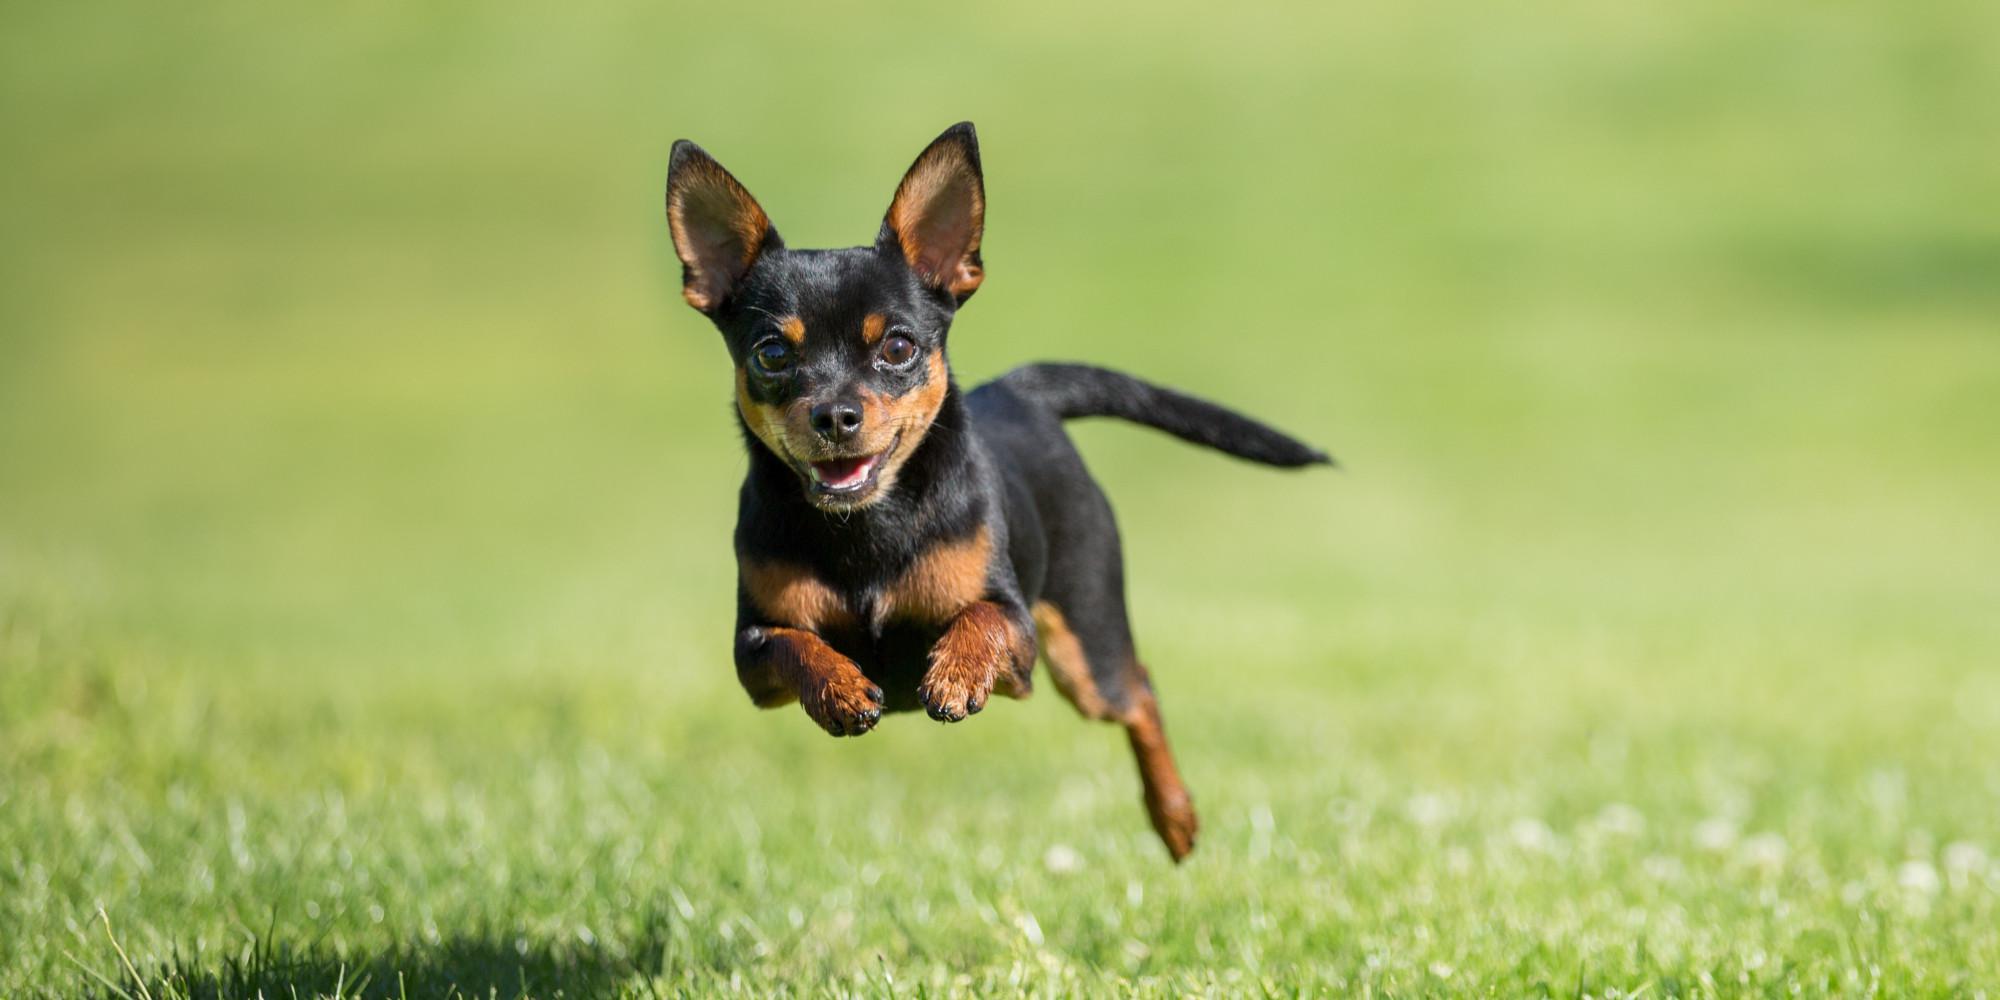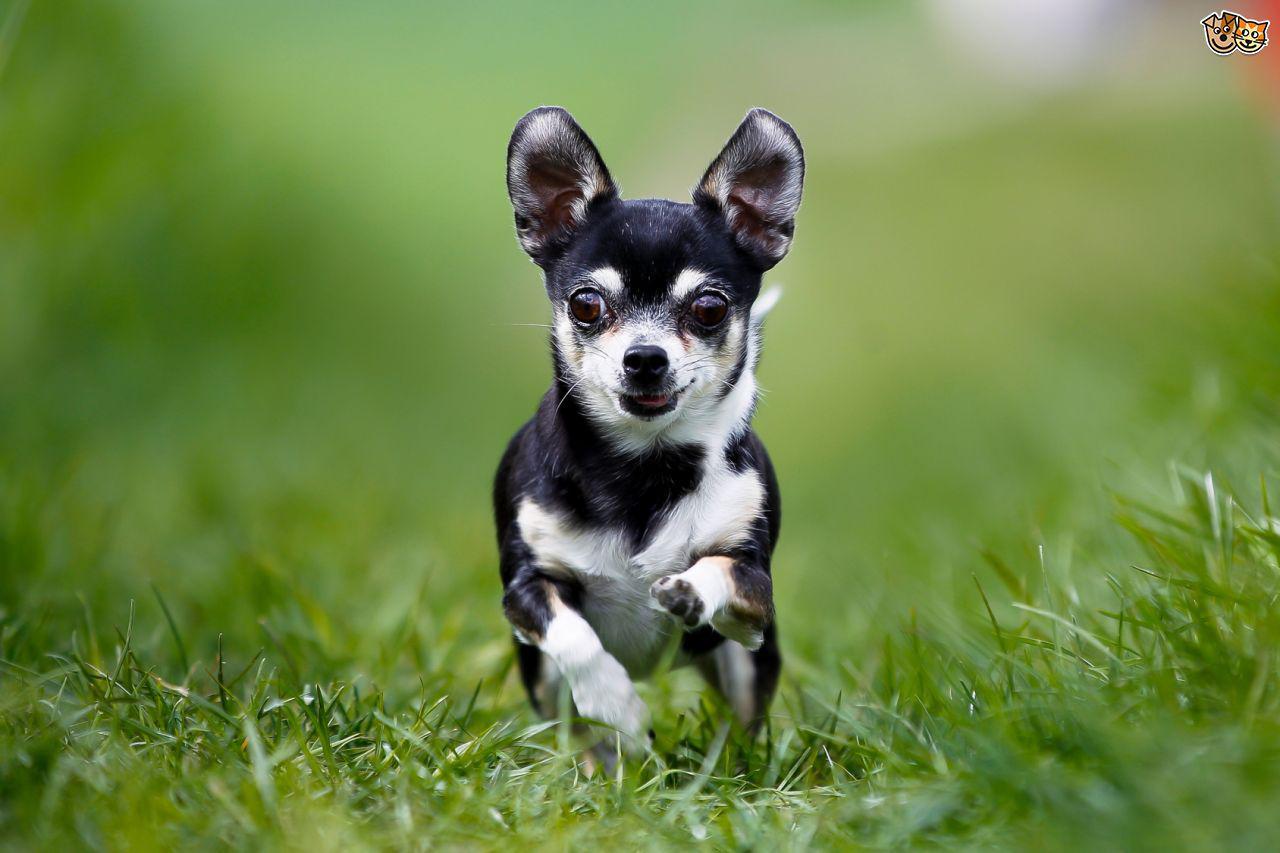The first image is the image on the left, the second image is the image on the right. For the images displayed, is the sentence "there is a mostly black dog leaping through the air in the image on the left" factually correct? Answer yes or no. Yes. The first image is the image on the left, the second image is the image on the right. Examine the images to the left and right. Is the description "All dogs in the images are running across the grass." accurate? Answer yes or no. Yes. 